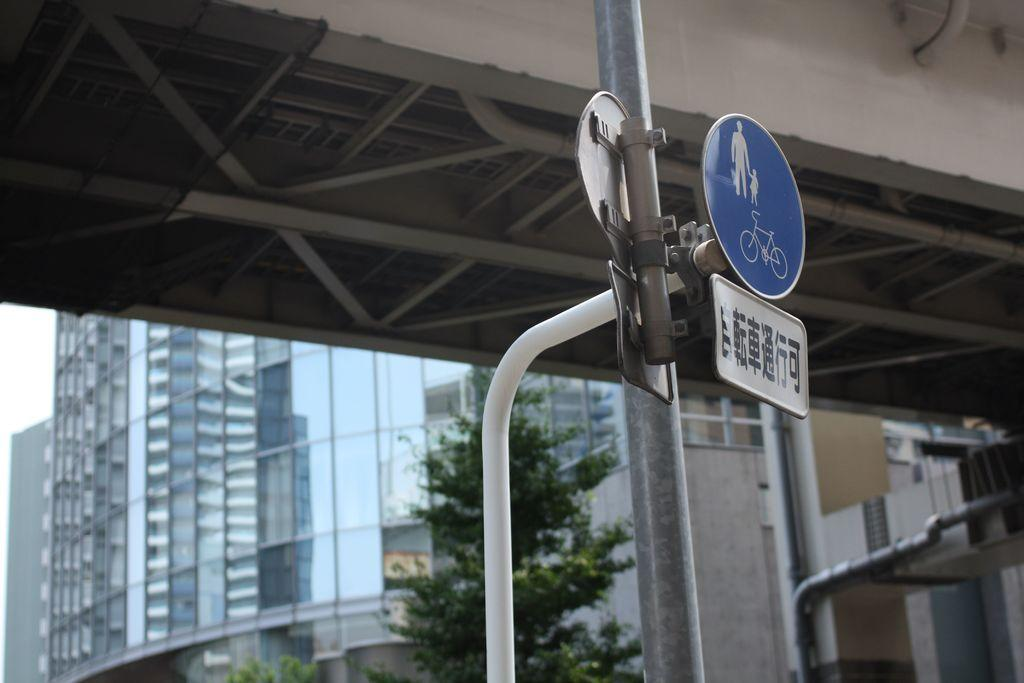What is the main object in the image? There is a pole in the image. What is attached to the pole? A sign board is attached to the pole. What can be seen in the background of the image? There are buildings and trees in the background of the image. Are there any fairies visible around the pole in the image? There are no fairies present in the image. What type of steel is used to construct the pole in the image? The image does not provide information about the type of steel used to construct the pole. 